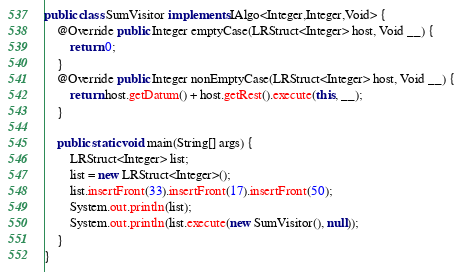<code> <loc_0><loc_0><loc_500><loc_500><_Java_>
public class SumVisitor implements IAlgo<Integer,Integer,Void> {
	@Override public Integer emptyCase(LRStruct<Integer> host, Void __) {
		return 0;
	}
	@Override public Integer nonEmptyCase(LRStruct<Integer> host, Void __) {
		return host.getDatum() + host.getRest().execute(this, __);
	}
	
	public static void main(String[] args) {
		LRStruct<Integer> list;
		list = new LRStruct<Integer>();
		list.insertFront(33).insertFront(17).insertFront(50);
		System.out.println(list);
		System.out.println(list.execute(new SumVisitor(), null));
	}
}
</code> 